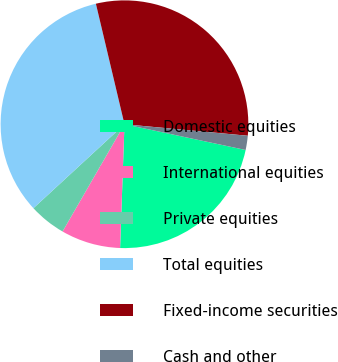Convert chart. <chart><loc_0><loc_0><loc_500><loc_500><pie_chart><fcel>Domestic equities<fcel>International equities<fcel>Private equities<fcel>Total equities<fcel>Fixed-income securities<fcel>Cash and other<nl><fcel>22.23%<fcel>7.77%<fcel>4.81%<fcel>33.15%<fcel>30.19%<fcel>1.85%<nl></chart> 